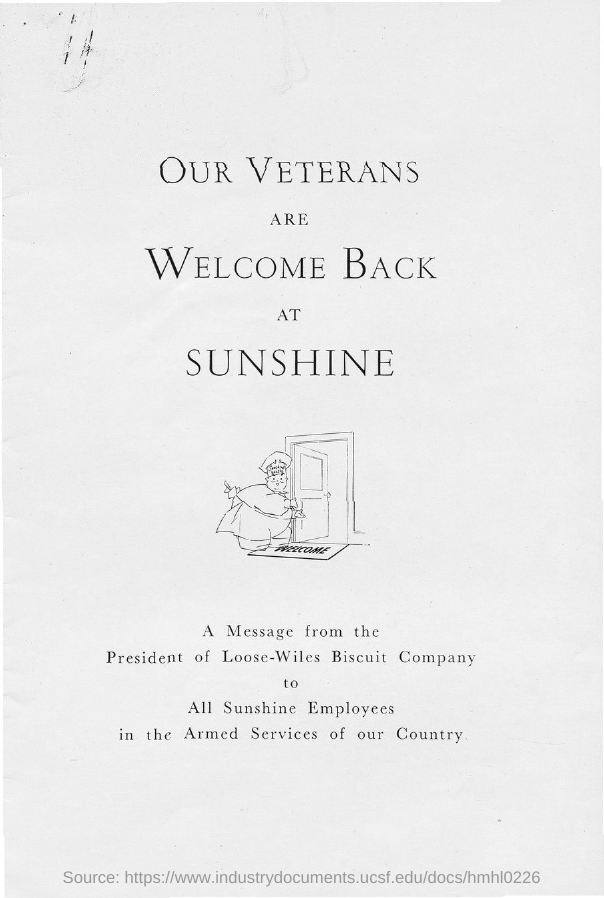What is the title of the document?
Ensure brevity in your answer.  Our veterans are welcome back at sunshine. 